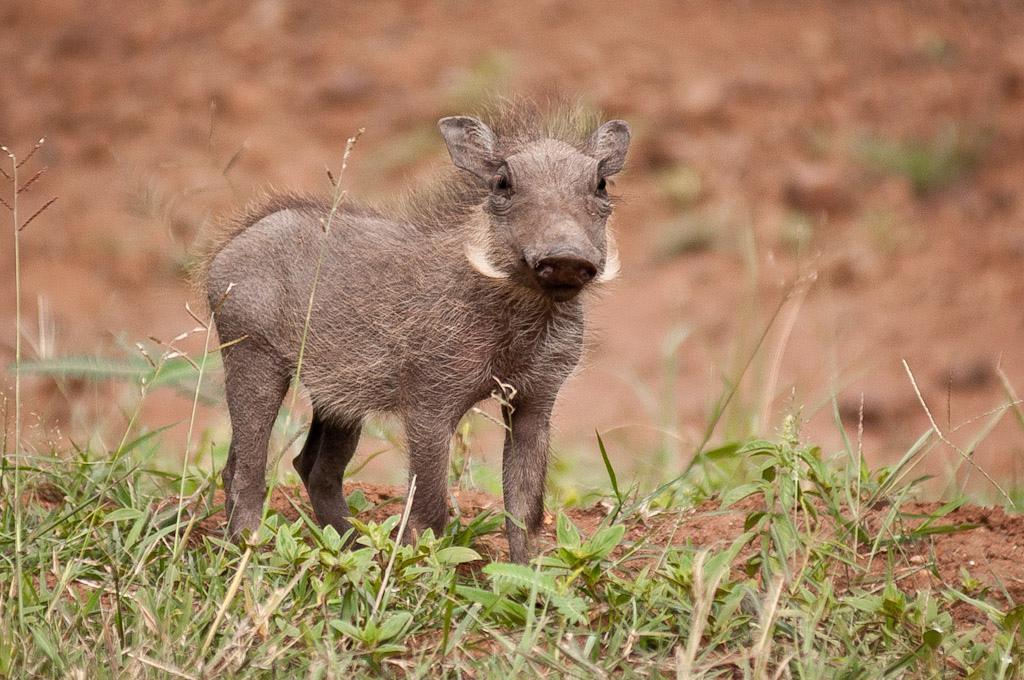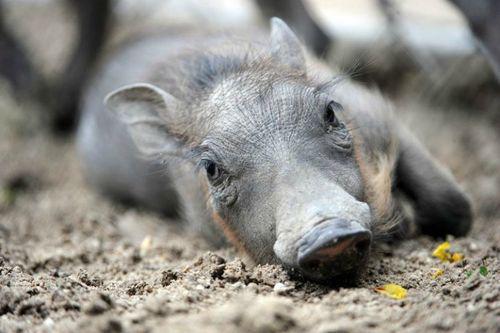The first image is the image on the left, the second image is the image on the right. Assess this claim about the two images: "One of the animals is lying down on the ground.". Correct or not? Answer yes or no. Yes. The first image is the image on the left, the second image is the image on the right. Examine the images to the left and right. Is the description "Left and right images contain the same number of warthogs, and the combined images contain at least four warthogs." accurate? Answer yes or no. No. 